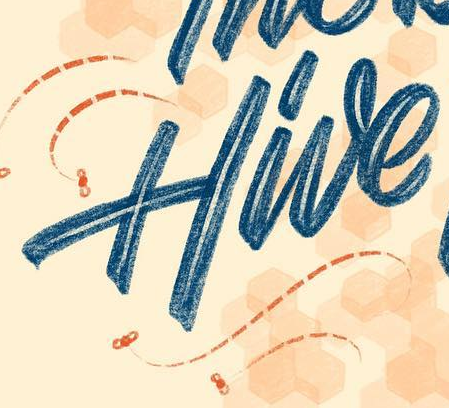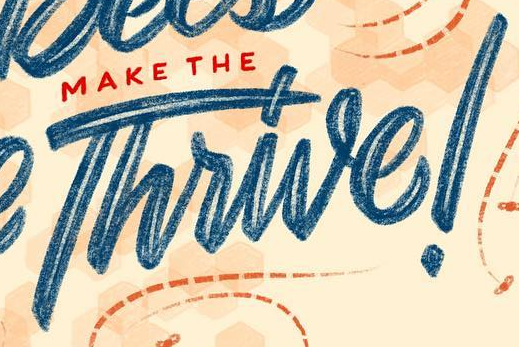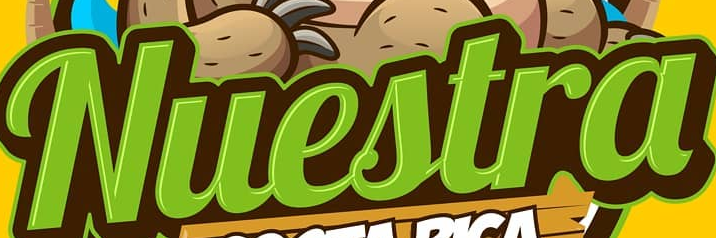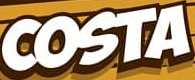What text appears in these images from left to right, separated by a semicolon? Hive; Thrive!; Nuestra; COSTA 